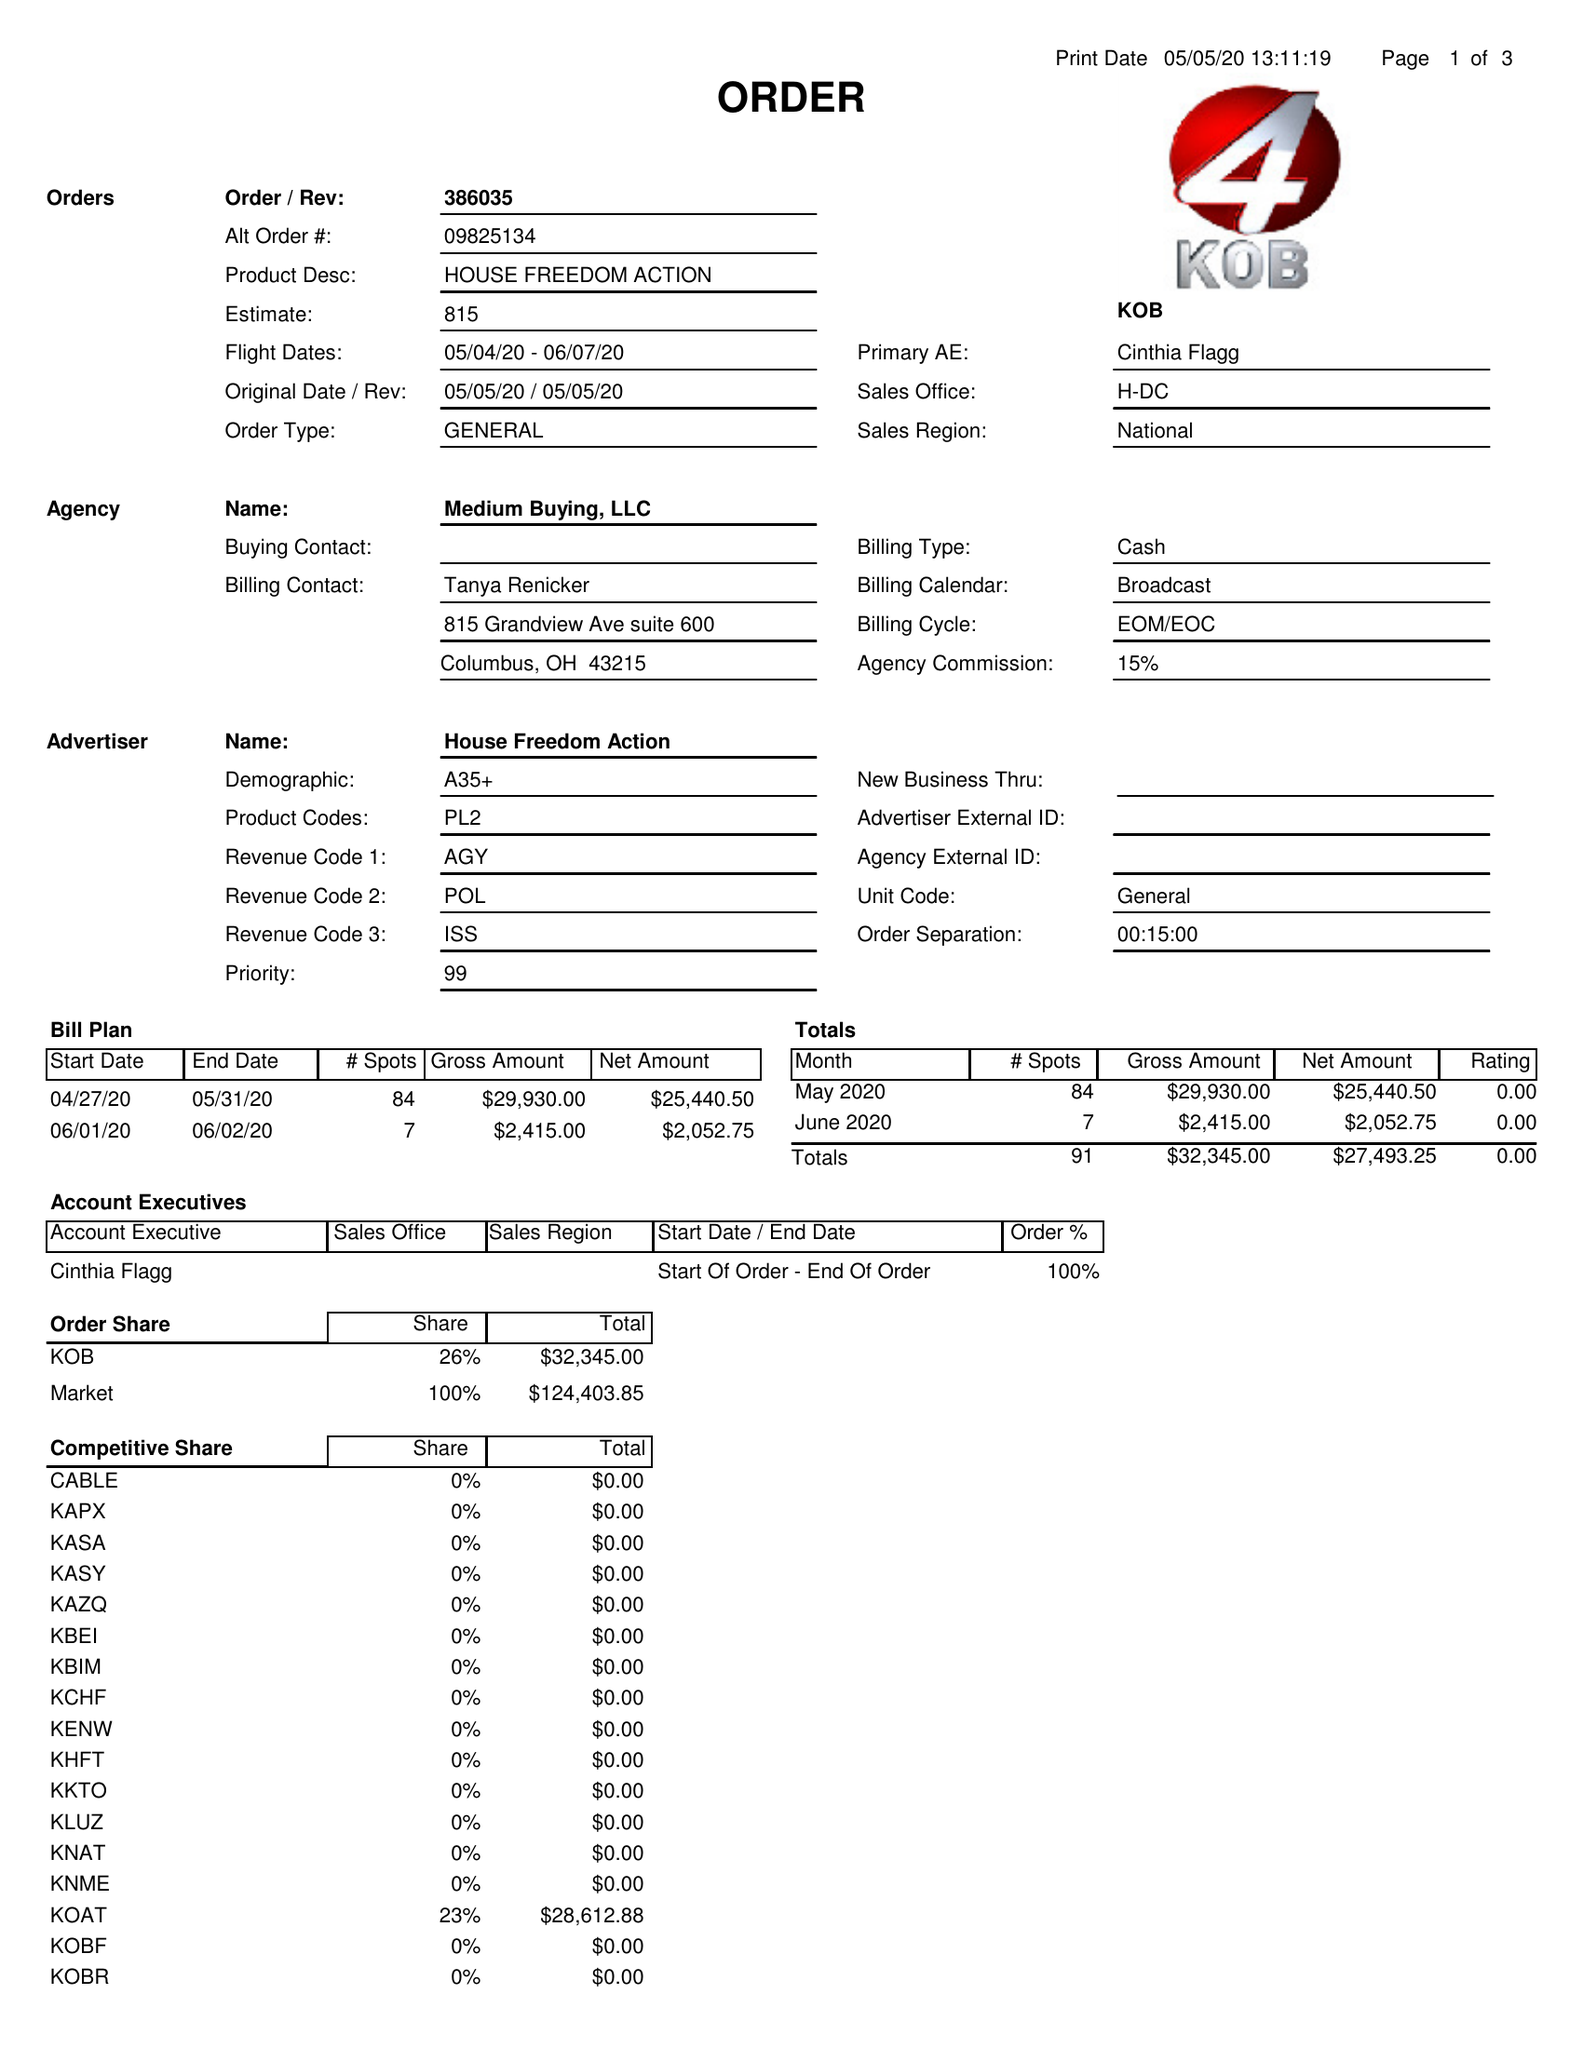What is the value for the advertiser?
Answer the question using a single word or phrase. HOUSE FREEDOM ACTION 